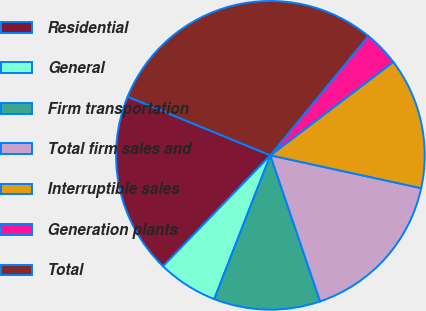Convert chart to OTSL. <chart><loc_0><loc_0><loc_500><loc_500><pie_chart><fcel>Residential<fcel>General<fcel>Firm transportation<fcel>Total firm sales and<fcel>Interruptible sales<fcel>Generation plants<fcel>Total<nl><fcel>18.96%<fcel>6.32%<fcel>11.15%<fcel>16.36%<fcel>13.75%<fcel>3.72%<fcel>29.74%<nl></chart> 